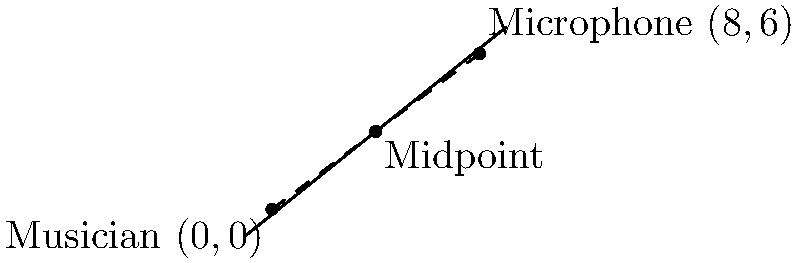During a stage setup, a musician is positioned at coordinates $(0,0)$ and a microphone stand is placed at $(8,6)$. To optimize sound quality, you need to find the midpoint between these two positions. What are the coordinates of this midpoint? To find the midpoint between two points, we use the midpoint formula:

$$ M_x = \frac{x_1 + x_2}{2}, \quad M_y = \frac{y_1 + y_2}{2} $$

Where $(x_1, y_1)$ is the first point and $(x_2, y_2)$ is the second point.

1. Identify the coordinates:
   - Musician: $(x_1, y_1) = (0, 0)$
   - Microphone: $(x_2, y_2) = (8, 6)$

2. Calculate the x-coordinate of the midpoint:
   $$ M_x = \frac{x_1 + x_2}{2} = \frac{0 + 8}{2} = \frac{8}{2} = 4 $$

3. Calculate the y-coordinate of the midpoint:
   $$ M_y = \frac{y_1 + y_2}{2} = \frac{0 + 6}{2} = \frac{6}{2} = 3 $$

4. Combine the results to get the midpoint coordinates:
   $$ M = (M_x, M_y) = (4, 3) $$
Answer: $(4,3)$ 